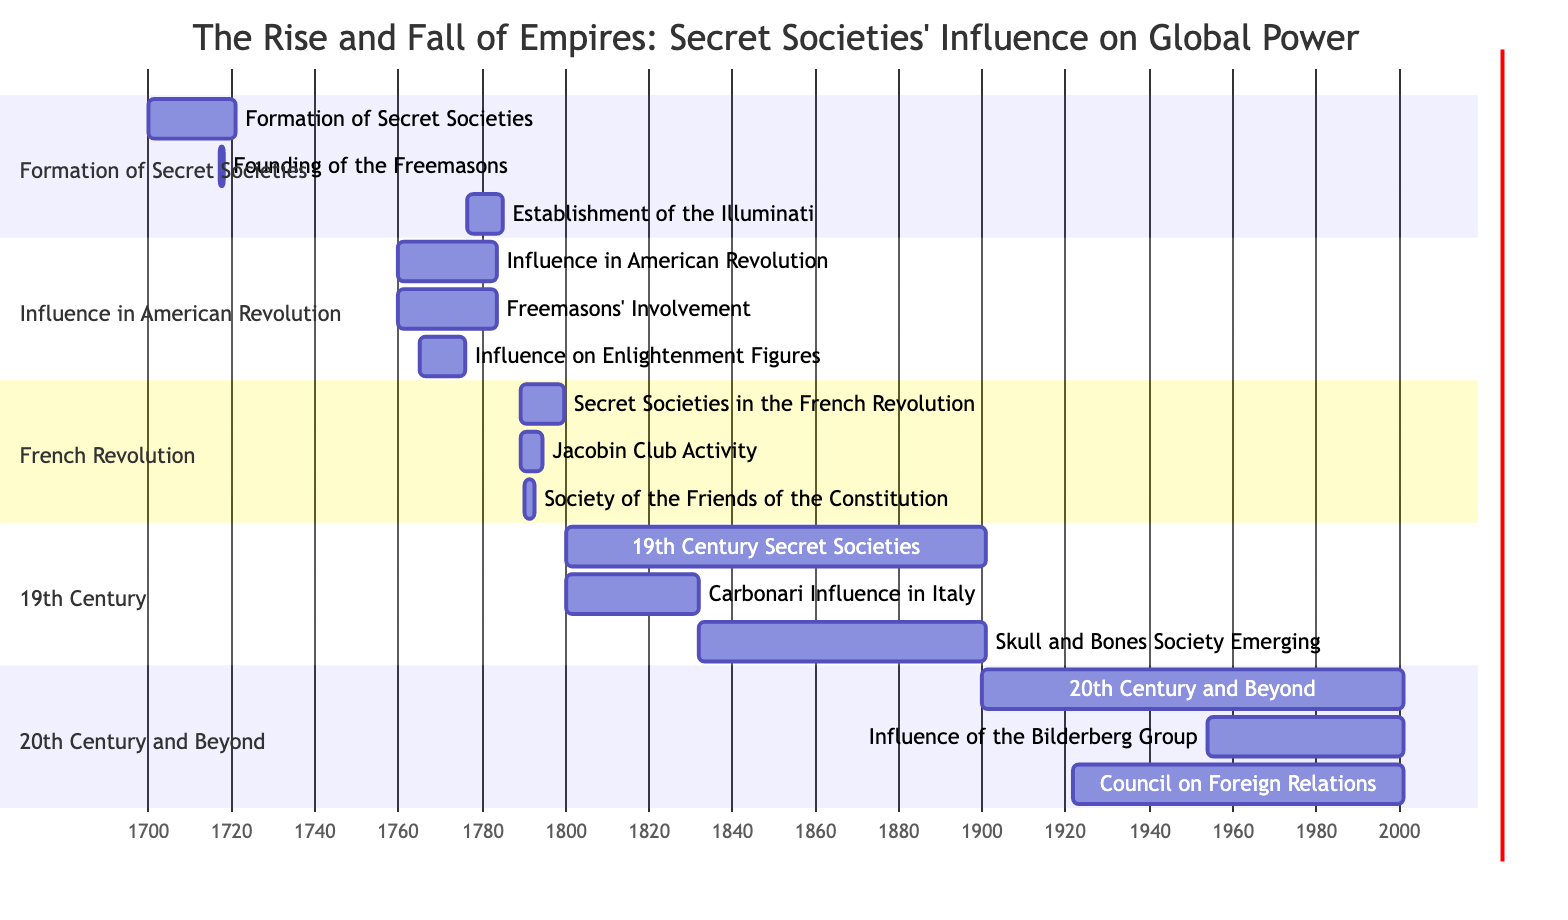What's the total duration of the "Formation of Secret Societies"? The "Formation of Secret Societies" starts in 1700 and ends in 1720. To find the total duration, subtract the start year from the end year: 1720 - 1700 = 20 years.
Answer: 20 years Which secret society was founded in the year 1717? The diagram specifies that the "Founding of the Freemasons" occurred in 1717. This detail is clearly indicated as a subtask under the "Formation of Secret Societies" section.
Answer: Freemasons What are the starting and ending years for "Influence on Enlightenment Figures"? The "Influence on Enlightenment Figures" starts in 1765 and ends in 1775. These dates are provided directly in the subtasks of "Influence in American Revolution."
Answer: 1765-1775 In which section does the "Jacobin Club Activity" appear? The "Jacobin Club Activity" is listed under the section "Secret Societies in the French Revolution." This section encompasses all related tasks to the French Revolution's events regarding secret societies.
Answer: Secret Societies in the French Revolution What is the earliest year mentioned in the diagram? Scanning the diagram shows that the earliest year recorded is 1700, the starting date for "Formation of Secret Societies." This date marks the beginning of the timeline for the entire chart.
Answer: 1700 How many subtasks are associated with the "19th Century Secret Societies"? The section "19th Century Secret Societies" includes two subtasks: "Carbonari Influence in Italy" and "Skull and Bones Society Emerging." Counting these subtasks provides the total.
Answer: 2 When did the "Council on Foreign Relations" start? According to the Gantt chart, the "Council on Foreign Relations" began on July 29, 1921. This detail is clearly noted in the 20th Century and Beyond section of the chart.
Answer: 1921-07-29 Which secret society's influence is noted from 1954 to 2000? The diagram states that the "Influence of the Bilderberg Group" spans from 1954 to 2000, as detailed in the 20th Century and Beyond section. The timeline indicates this range clearly.
Answer: Bilderberg Group What is the timeframe of the "Society of the Friends of the Constitution"? The "Society of the Friends of the Constitution" operates from January 1, 1790, to October 10, 1792. This specific time frame can be read directly from the subtasks under "Secret Societies in the French Revolution."
Answer: 1790-1792 